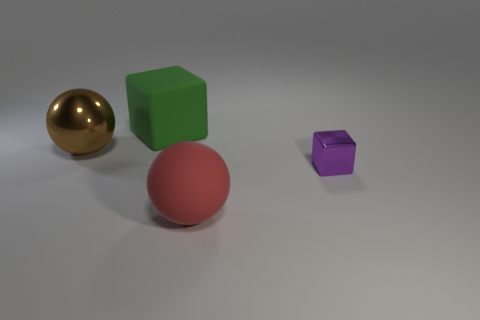Is the material of the big ball that is behind the red rubber sphere the same as the purple block?
Offer a very short reply. Yes. The big rubber thing that is the same shape as the small purple shiny object is what color?
Your answer should be very brief. Green. The small purple thing is what shape?
Offer a terse response. Cube. What number of objects are either small purple shiny objects or small gray blocks?
Your response must be concise. 1. Does the matte thing that is left of the red sphere have the same color as the cube in front of the metallic ball?
Make the answer very short. No. Are there any tiny cyan matte cylinders?
Your response must be concise. No. How many things are red cylinders or shiny things that are to the right of the large shiny thing?
Provide a short and direct response. 1. Is the size of the shiny object that is on the left side of the purple metal thing the same as the tiny purple cube?
Make the answer very short. No. How many other things are the same size as the purple cube?
Give a very brief answer. 0. The tiny thing has what color?
Your answer should be compact. Purple. 